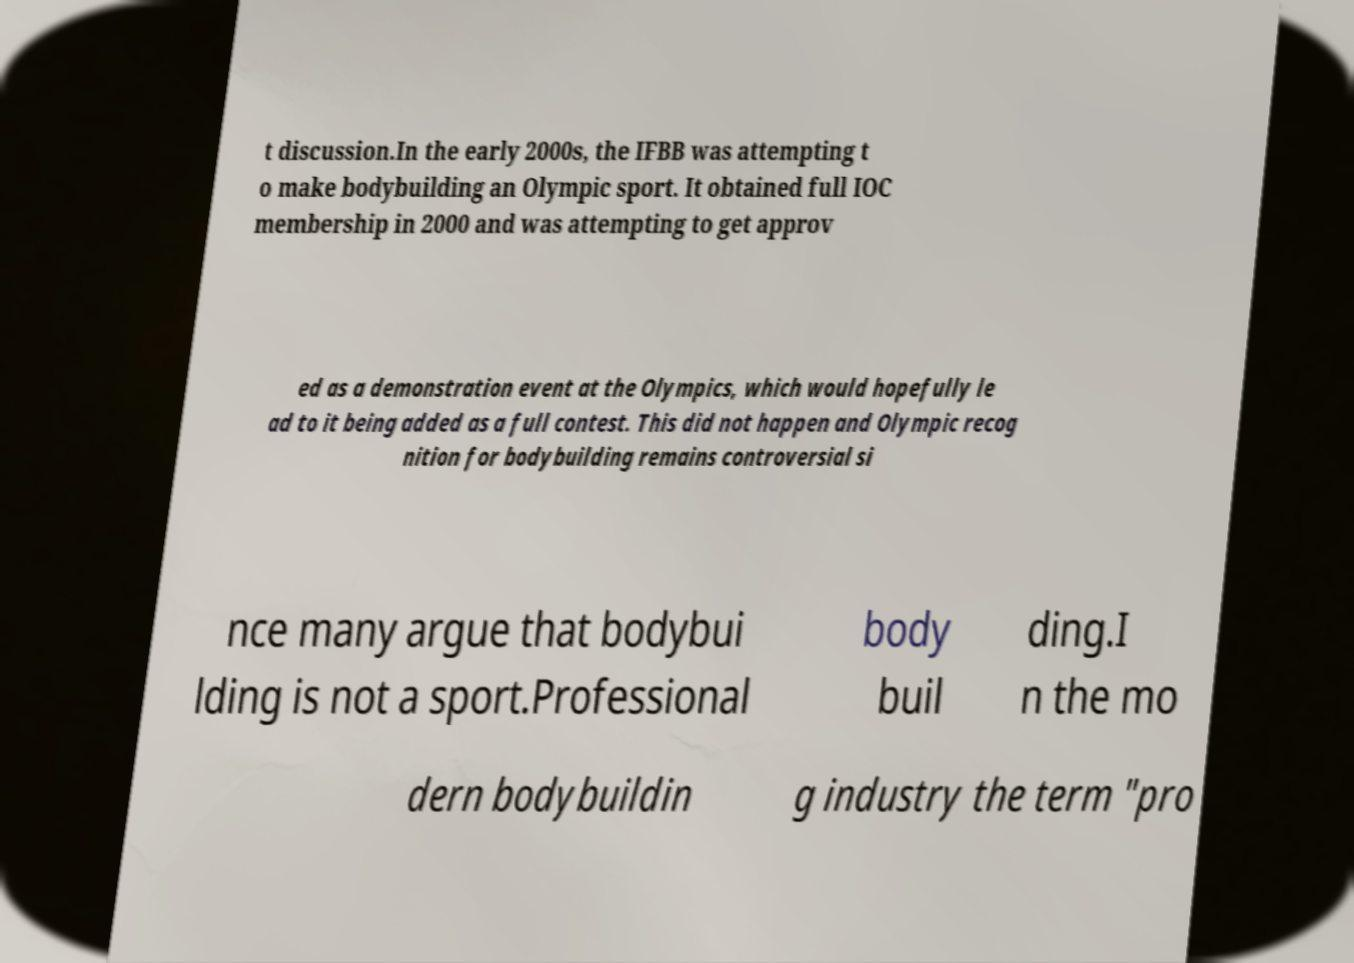Please read and relay the text visible in this image. What does it say? t discussion.In the early 2000s, the IFBB was attempting t o make bodybuilding an Olympic sport. It obtained full IOC membership in 2000 and was attempting to get approv ed as a demonstration event at the Olympics, which would hopefully le ad to it being added as a full contest. This did not happen and Olympic recog nition for bodybuilding remains controversial si nce many argue that bodybui lding is not a sport.Professional body buil ding.I n the mo dern bodybuildin g industry the term "pro 